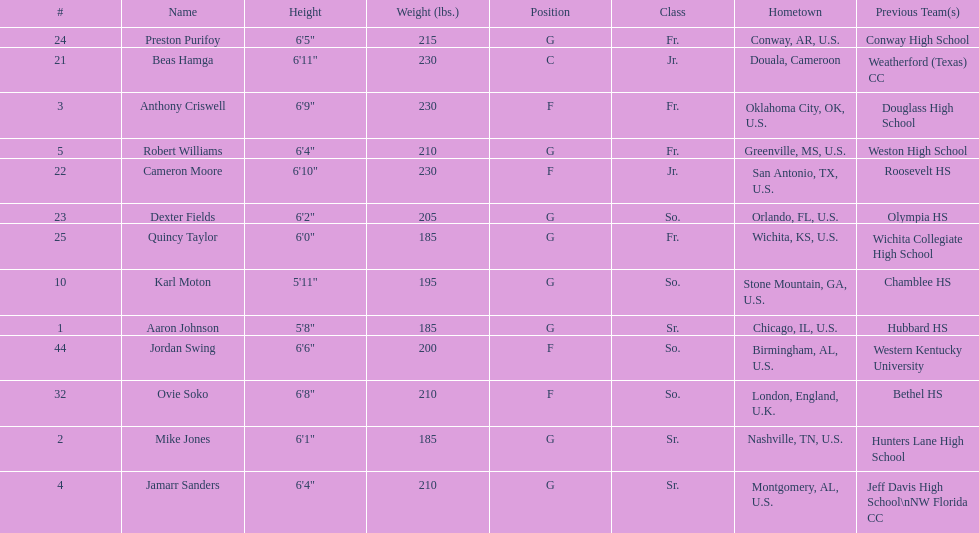Which are all of the players? Aaron Johnson, Anthony Criswell, Jamarr Sanders, Robert Williams, Karl Moton, Beas Hamga, Cameron Moore, Dexter Fields, Preston Purifoy, Ovie Soko, Mike Jones, Quincy Taylor, Jordan Swing. Which players are from a country outside of the u.s.? Beas Hamga, Ovie Soko. Aside from soko, who else is not from the u.s.? Beas Hamga. 